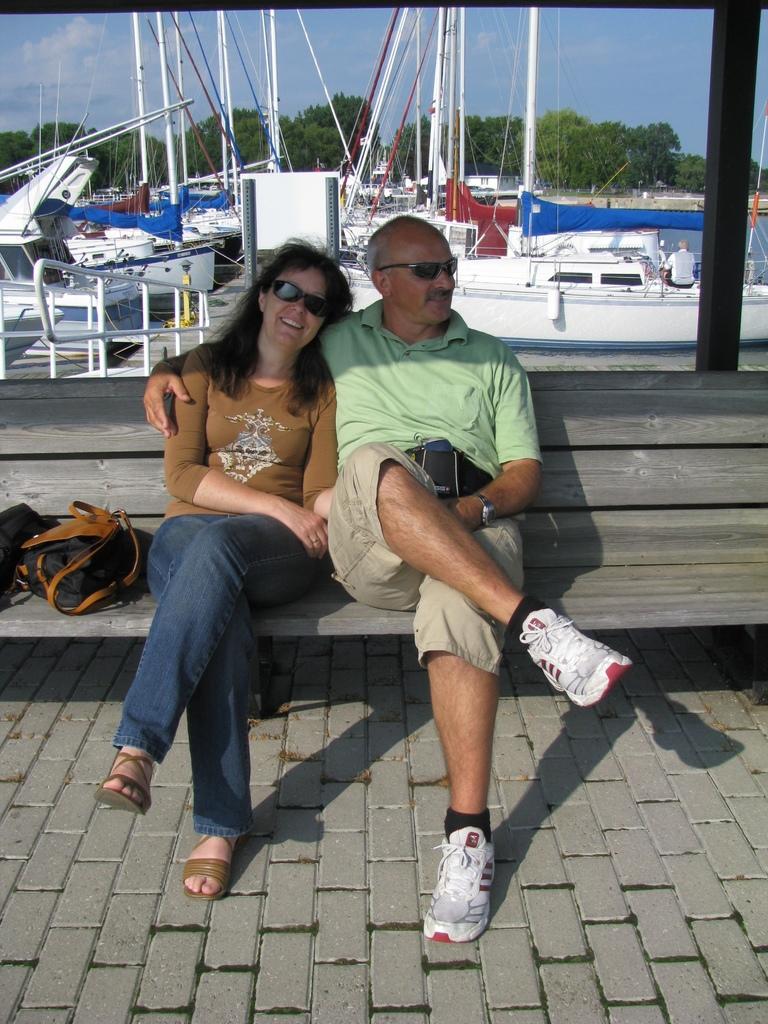In one or two sentences, can you explain what this image depicts? In the picture there is old man and a woman with a bag sitting on bench. in the background there are boats on the sea and to the whole background there are several trees, sky with clouds. 